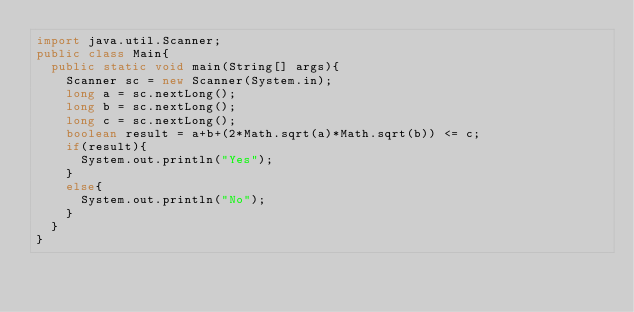<code> <loc_0><loc_0><loc_500><loc_500><_Java_>import java.util.Scanner;
public class Main{
  public static void main(String[] args){
    Scanner sc = new Scanner(System.in);
    long a = sc.nextLong();
    long b = sc.nextLong();
    long c = sc.nextLong();
    boolean result = a+b+(2*Math.sqrt(a)*Math.sqrt(b)) <= c;
    if(result){
      System.out.println("Yes");
    }
    else{
      System.out.println("No");
    }
  }
}</code> 